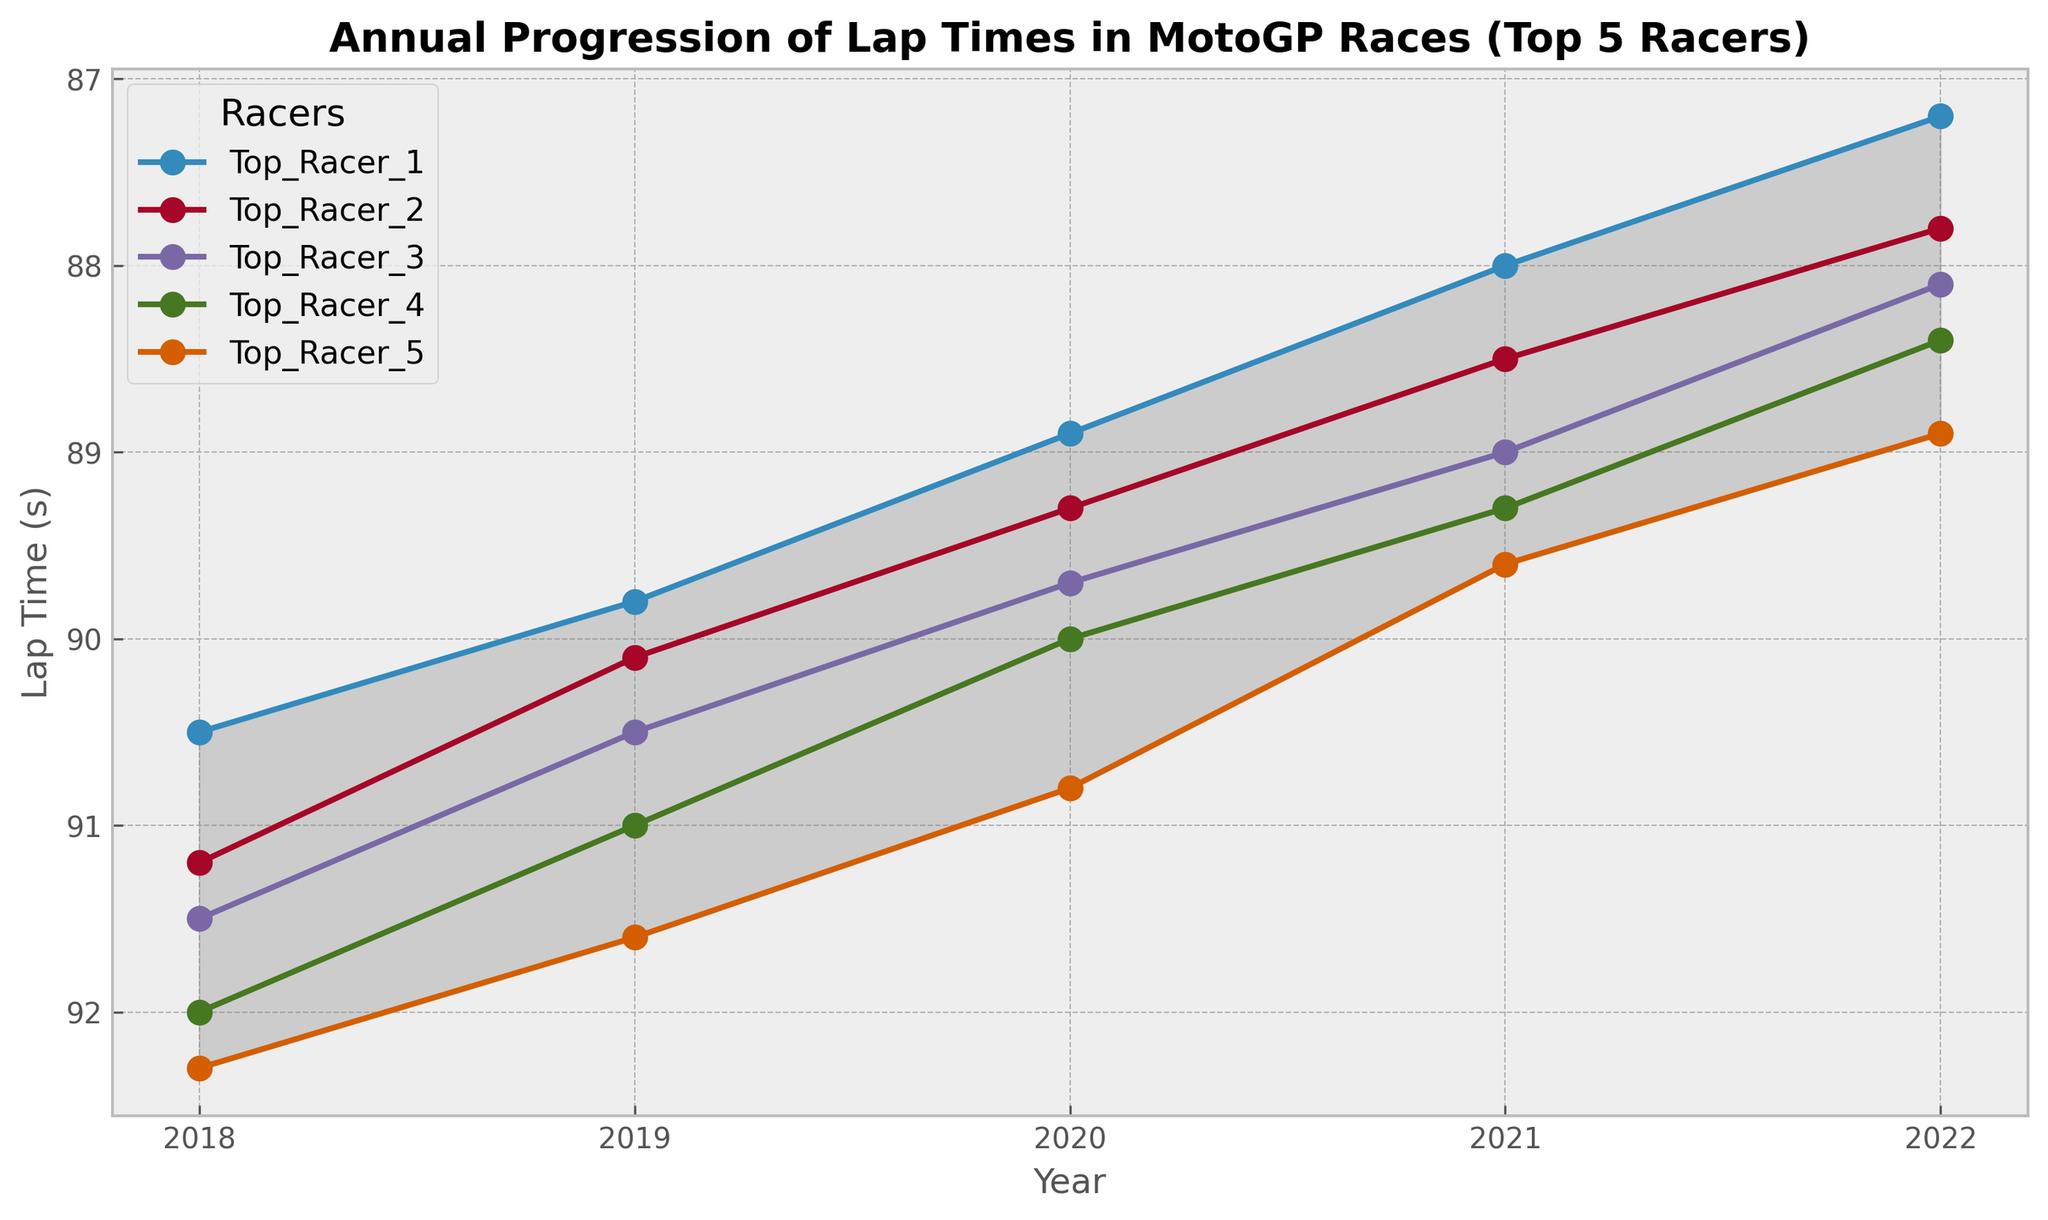Which racer had the fastest lap time in 2021? The fastest lap time in 2021 is indicated by the lowest point on the y-axis for that year. In 2021, Top_Racer_1 has the fastest lap time.
Answer: Top_Racer_1 How did Top_Racer_1's lap time change from 2018 to 2022? To find the change, subtract the 2022 lap time from the 2018 lap time for Top_Racer_1. In 2018, the lap time was 90.5s and in 2022 it was 87.2s. So, the change is 90.5 - 87.2 = 3.3s.
Answer: Decreased by 3.3s In which year was the gap between the fastest and the slowest lap times the smallest? To find the year with the smallest gap, compare the differences between the fastest and slowest lap times for each year. The years are listed as columns where Top_Racer_1 has the fastest time and Top_Racer_5 has the slowest. The differences are:  
2018: 92.3 - 90.5 = 1.8s  
2019: 91.6 - 89.8 = 1.8s  
2020: 90.8 - 88.9 = 1.9s  
2021: 89.6 - 88.0 = 1.6s  
2022: 88.9 - 87.2 = 1.7s  
The smallest gap is in 2021.
Answer: 2021 What trend can be observed in the lap times of Top_Racer_2 from 2018 to 2022? Observe the plotted line for Top_Racer_2. The lap times consistently decrease each year from 91.2s in 2018 to 87.8s in 2022.
Answer: Decreasing trend How many years did Top_Racer_3 show improvement, i.e., a decreasing lap time compared to the previous year? Check each consecutive year's lap time for Top_Racer_3 to see if it is lower than the previous year.  
2018 to 2019: 91.5 to 90.5 (Improvement)  
2019 to 2020: 90.5 to 89.7 (Improvement)  
2020 to 2021: 89.7 to 89.0 (Improvement)  
2021 to 2022: 89.0 to 88.1 (Improvement)  
This shows 4 years of improvement.
Answer: 4 years By how much did the lap time of Top_Racer_4 change from 2019 to 2020? Compare the lap times of Top_Racer_4 in 2019 and 2020. In 2019 it was 91.0s and in 2020 it was 90.0s. The change is 91.0 - 90.0 = 1.0s.
Answer: Decreased by 1.0s Which year shows the highest lap time for Top_Racer_5? Identify the highest value in the line corresponding to Top_Racer_5. The highest lap time is 92.3s in 2018.
Answer: 2018 